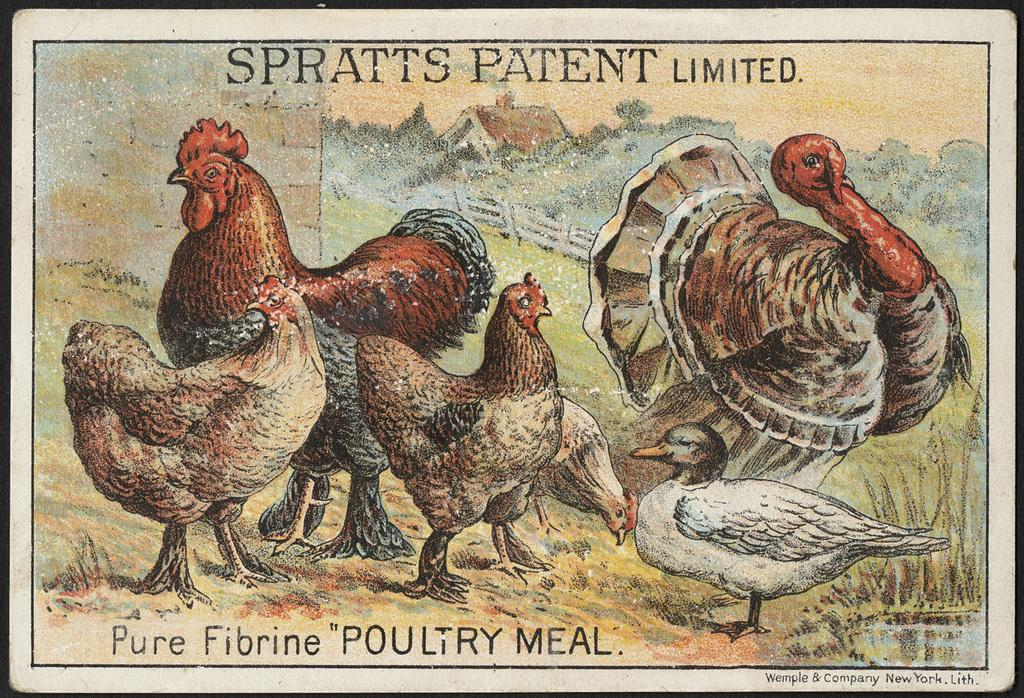What type of animals can be seen in the image? There are birds in the image. What type of vegetation is present in the image? There are trees and grass in the image. What type of structure can be seen in the image? There is a shed in the image. What part of the natural environment is visible in the image? The sky is visible in the image. What additional elements are present in the image? There is text at the top and bottom of the image. What type of lock is holding the queen in the image? There is no queen or lock present in the image. 